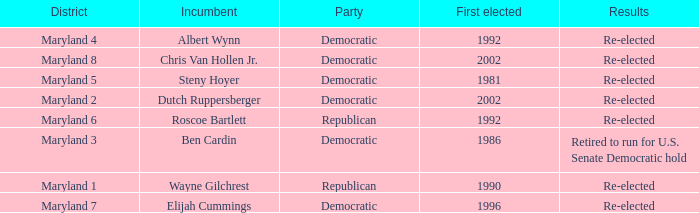Who is the incumbent who was first elected before 2002 from the maryland 3 district? Ben Cardin. 